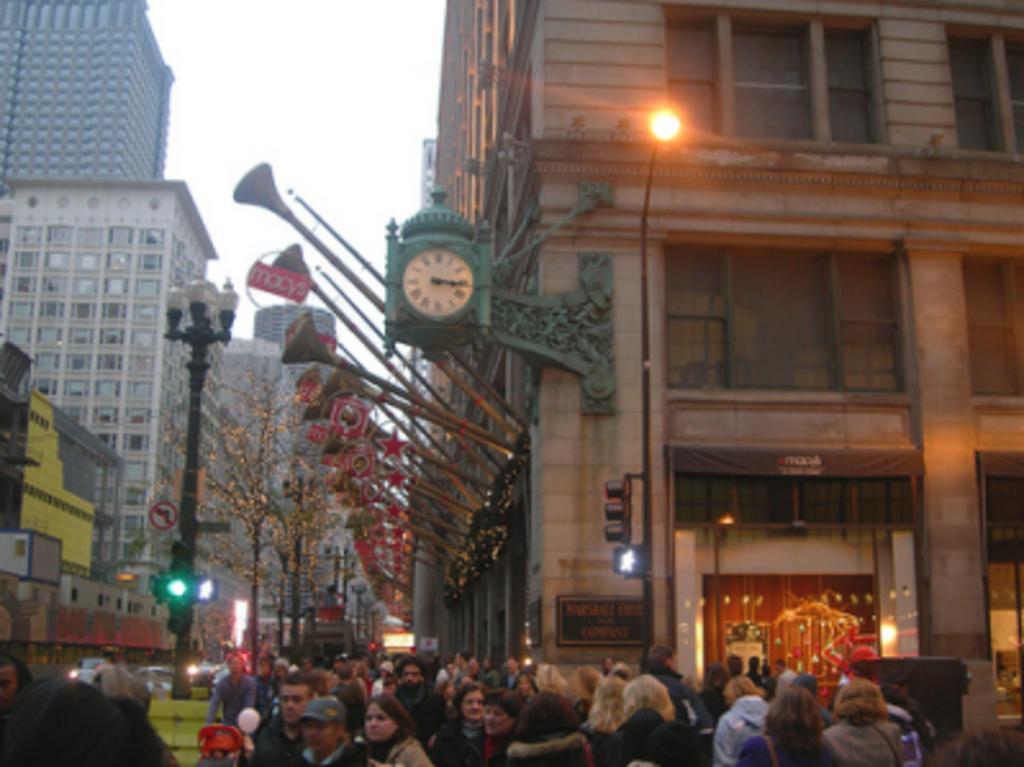In one or two sentences, can you explain what this image depicts? At the bottom of this image, there are persons in different color dresses. Beside them, there are signal lights, a sign board and lights attached to a pole. Above them, there are a clock and sticks attached to a wall of a building. Beside them, there is a light attached to the other pole. In the background, there are trees, buildings which are having glass windows and there is sky. 